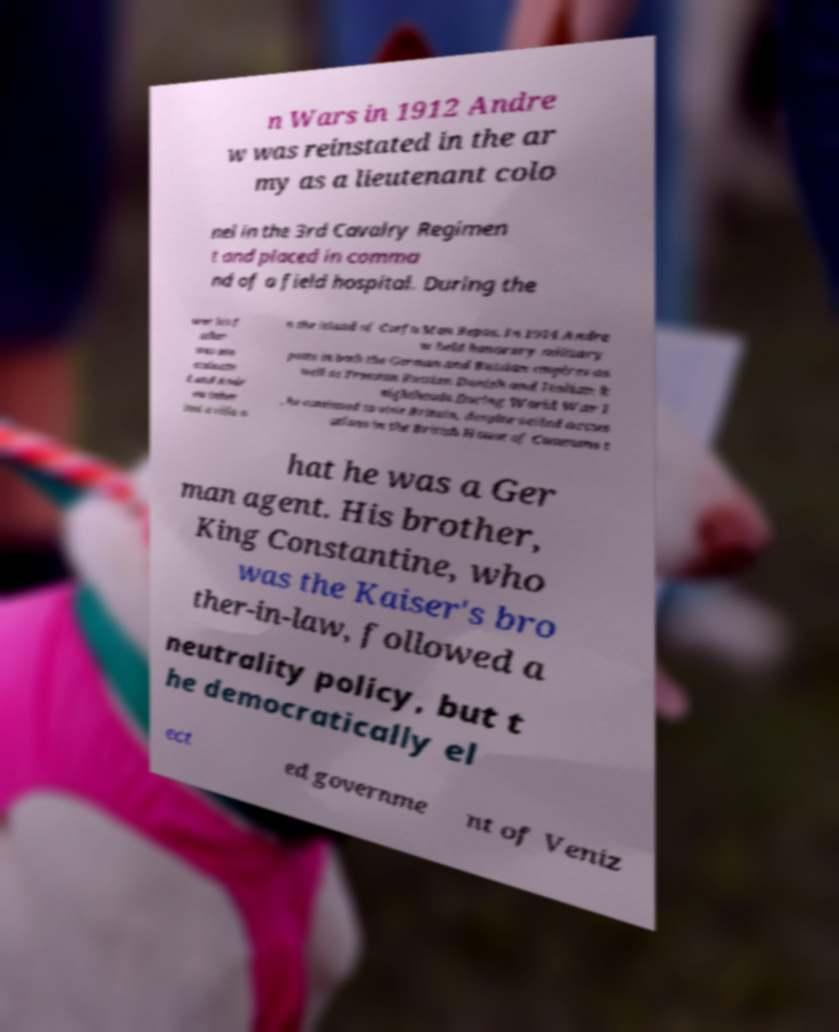Could you extract and type out the text from this image? n Wars in 1912 Andre w was reinstated in the ar my as a lieutenant colo nel in the 3rd Cavalry Regimen t and placed in comma nd of a field hospital. During the war his f ather was ass assinate d and Andr ew inher ited a villa o n the island of Corfu Mon Repos. In 1914 Andre w held honorary military posts in both the German and Russian empires as well as Prussian Russian Danish and Italian k nighthoods.During World War I , he continued to visit Britain, despite veiled accus ations in the British House of Commons t hat he was a Ger man agent. His brother, King Constantine, who was the Kaiser's bro ther-in-law, followed a neutrality policy, but t he democratically el ect ed governme nt of Veniz 